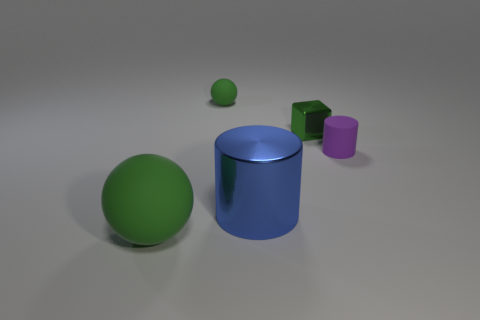Add 4 blue things. How many objects exist? 9 Subtract all cylinders. How many objects are left? 3 Add 1 small green metallic blocks. How many small green metallic blocks are left? 2 Add 2 yellow matte cubes. How many yellow matte cubes exist? 2 Subtract 0 green cylinders. How many objects are left? 5 Subtract all small cyan matte balls. Subtract all small cubes. How many objects are left? 4 